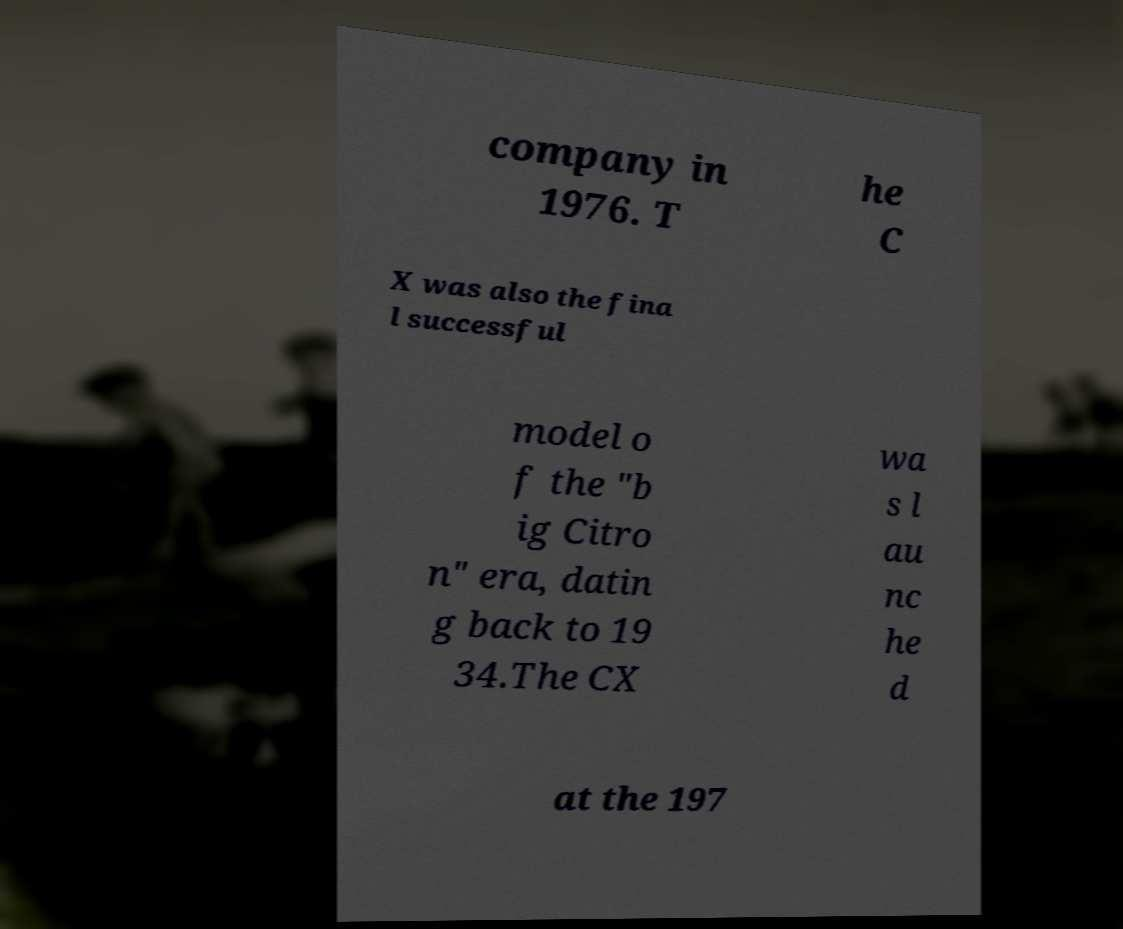For documentation purposes, I need the text within this image transcribed. Could you provide that? company in 1976. T he C X was also the fina l successful model o f the "b ig Citro n" era, datin g back to 19 34.The CX wa s l au nc he d at the 197 